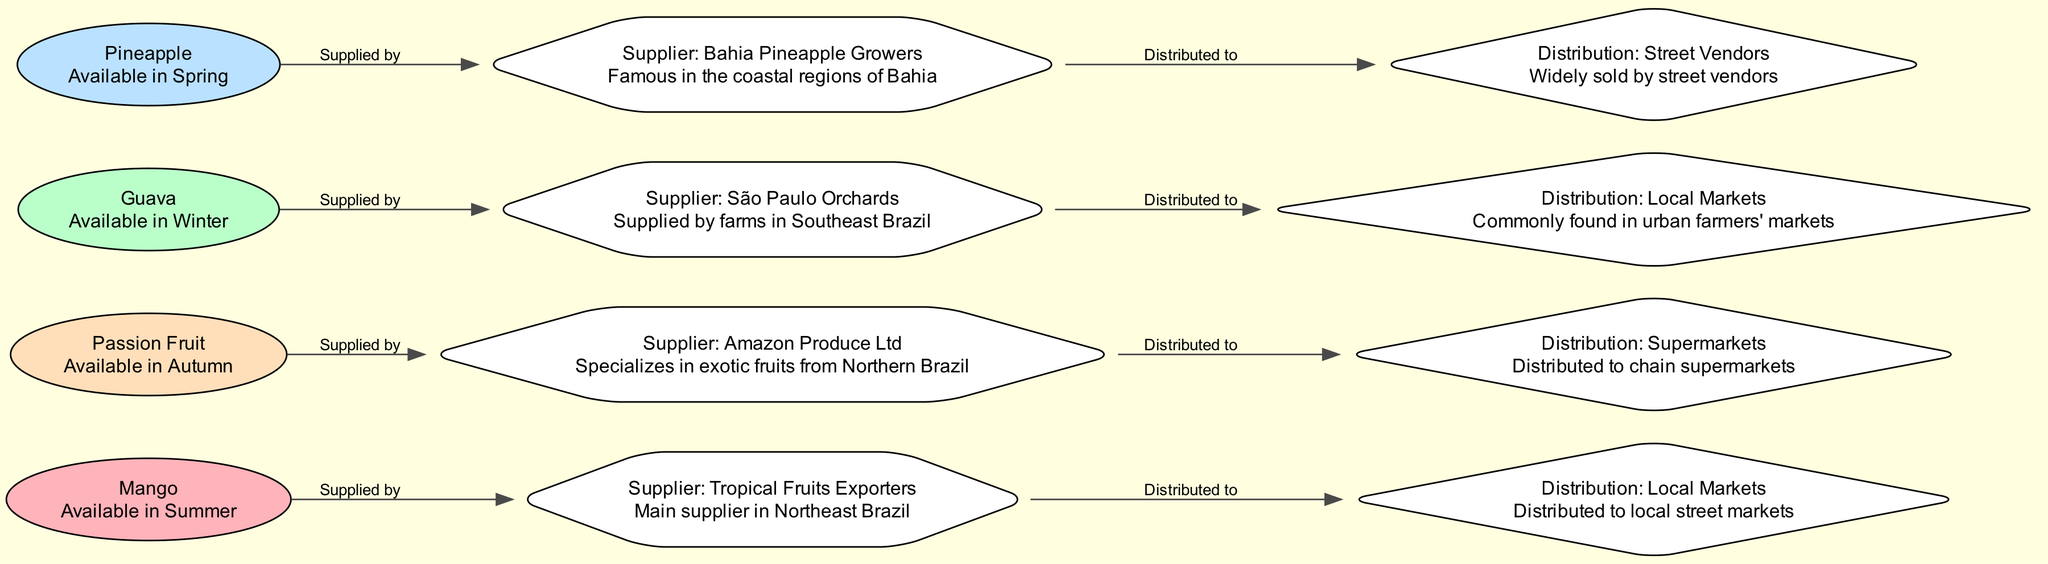What fruit is available in Summer? The diagram indicates that Mango is the fruit available in Summer as it is explicitly mentioned in the node description.
Answer: Mango Which fruit is supplied by Tropical Fruits Exporters? The diagram shows that Mango is supplied by Tropical Fruits Exporters as indicated in the connection between the Mango node and the MangoSupplier node.
Answer: Mango How many fruits are shown in the diagram? By counting the nodes in the diagram, we find a total of four fruits: Mango, Passion Fruit, Guava, and Pineapple.
Answer: 4 What type of distribution method is used for Guava? The diagram specifies that Guava is distributed to local markets, which is clearly mentioned in the GuavaDistribute node description.
Answer: Local Markets Which fruit is specialized by Amazon Produce Ltd? According to the diagram, Amazon Produce Ltd is the supplier for Passion Fruit, as shown in the edge connecting PassionFruit1 to PassionFruitSupplier.
Answer: Passion Fruit What season is represented by the color Light Pink in the diagram? Referring to the color coding in the diagram, Light Pink is associated with Summer, which is represented by the Mango node.
Answer: Summer Which fruit is widely sold by street vendors? The diagram indicates that Pineapple is the fruit widely sold by street vendors, based on the description in the PineappleDistribute node.
Answer: Pineapple Who specializes in exotic fruits from Northern Brazil? The diagram states that Amazon Produce Ltd specializes in exotic fruits from Northern Brazil, specifically supplying Passion Fruit.
Answer: Amazon Produce Ltd What is the distribution method for Pineapple? The diagram shows that Pineapple is distributed by street vendors, as mentioned in the PineappleDistribute node.
Answer: Street Vendors 